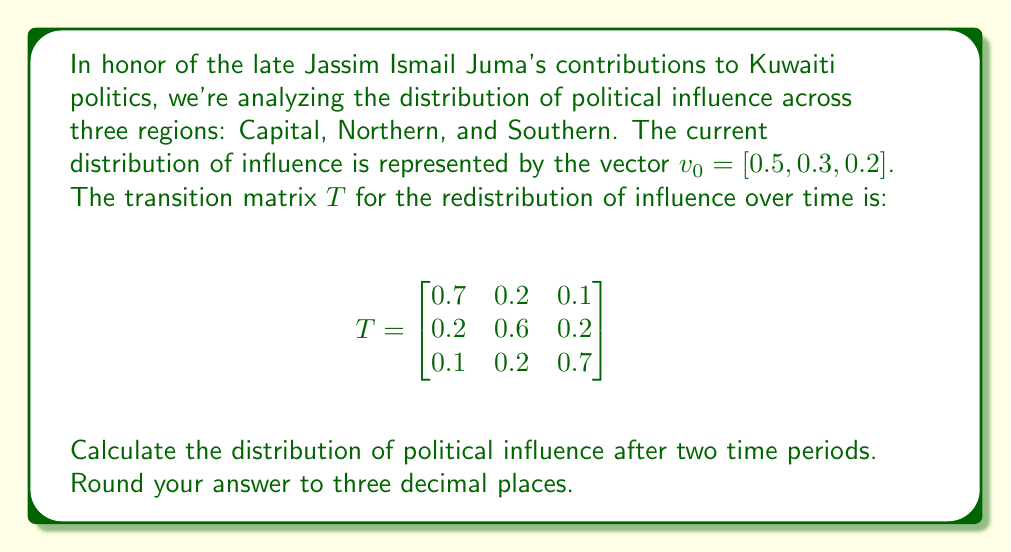Can you solve this math problem? To solve this problem, we need to multiply the initial distribution vector by the transition matrix twice. Let's go through this step-by-step:

1) First, let's calculate the distribution after one time period:
   $v_1 = v_0 \cdot T$

   $v_1 = [0.5, 0.3, 0.2] \cdot \begin{bmatrix}
   0.7 & 0.2 & 0.1 \\
   0.2 & 0.6 & 0.2 \\
   0.1 & 0.2 & 0.7
   \end{bmatrix}$

   $v_1 = [0.5(0.7) + 0.3(0.2) + 0.2(0.1), 0.5(0.2) + 0.3(0.6) + 0.2(0.2), 0.5(0.1) + 0.3(0.2) + 0.2(0.7)]$

   $v_1 = [0.35 + 0.06 + 0.02, 0.1 + 0.18 + 0.04, 0.05 + 0.06 + 0.14]$

   $v_1 = [0.43, 0.32, 0.25]$

2) Now, let's calculate the distribution after two time periods:
   $v_2 = v_1 \cdot T$

   $v_2 = [0.43, 0.32, 0.25] \cdot \begin{bmatrix}
   0.7 & 0.2 & 0.1 \\
   0.2 & 0.6 & 0.2 \\
   0.1 & 0.2 & 0.7
   \end{bmatrix}$

   $v_2 = [0.43(0.7) + 0.32(0.2) + 0.25(0.1), 0.43(0.2) + 0.32(0.6) + 0.25(0.2), 0.43(0.1) + 0.32(0.2) + 0.25(0.7)]$

   $v_2 = [0.301 + 0.064 + 0.025, 0.086 + 0.192 + 0.05, 0.043 + 0.064 + 0.175]$

   $v_2 = [0.390, 0.328, 0.282]$

3) Rounding to three decimal places:
   $v_2 = [0.390, 0.328, 0.282]$
Answer: [0.390, 0.328, 0.282] 